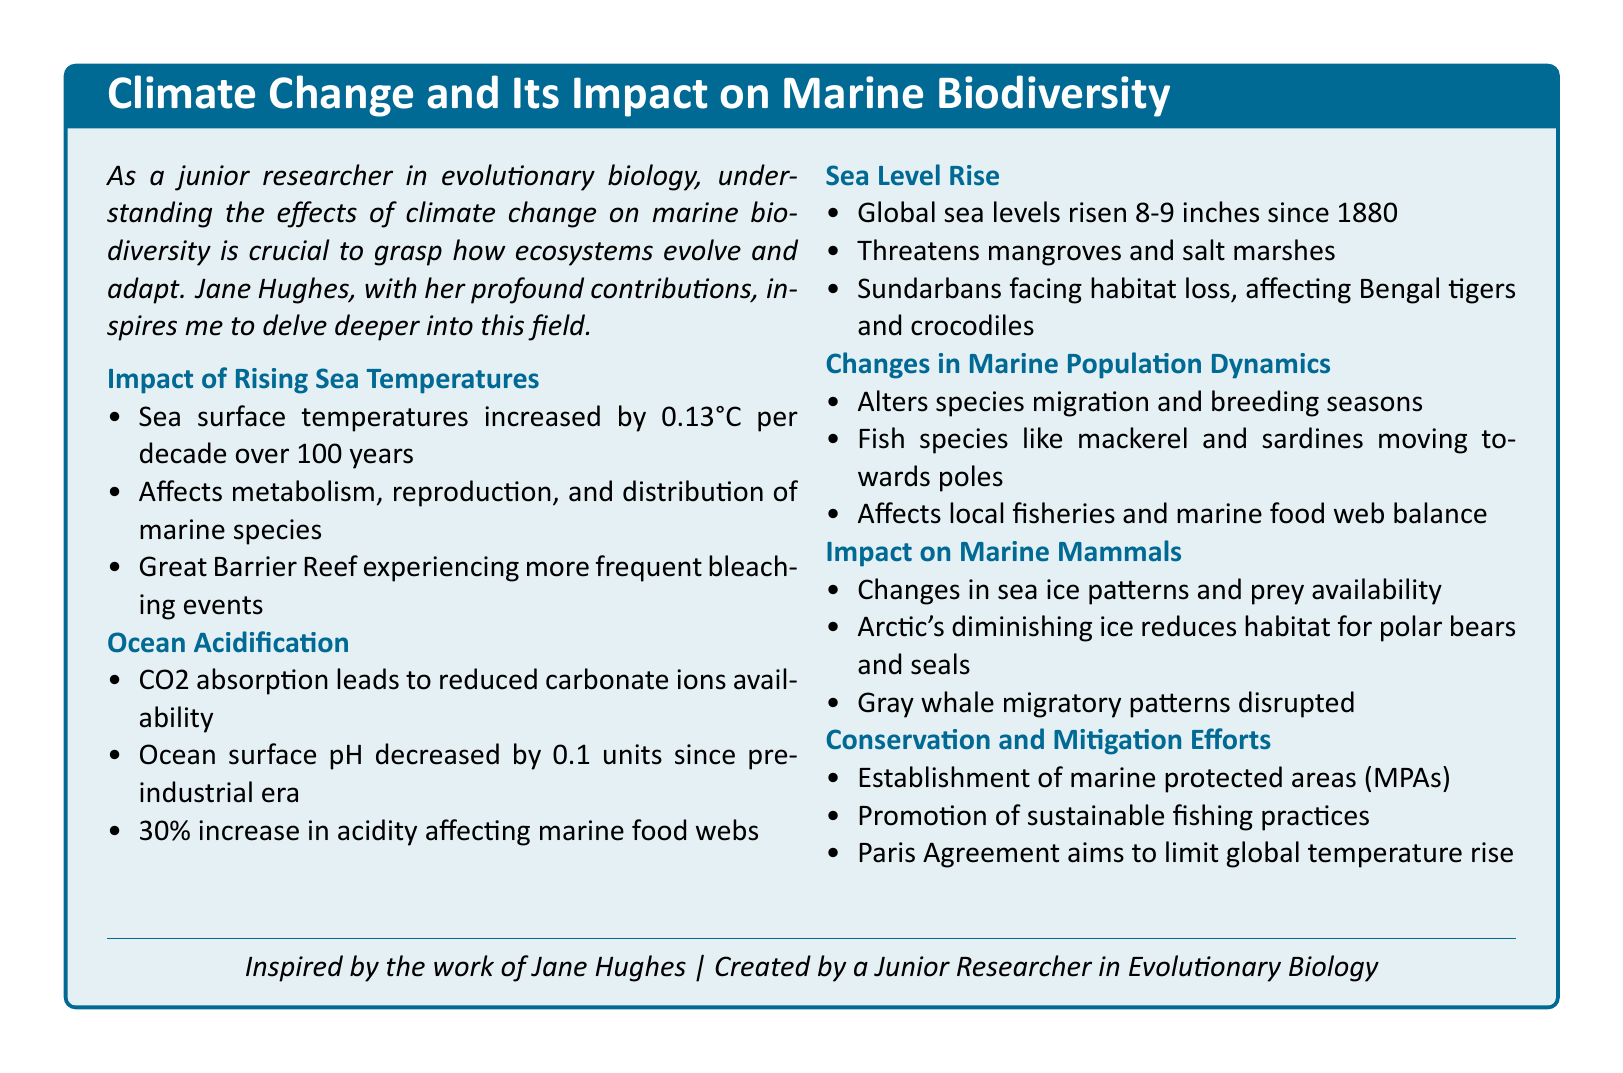What is the increase in sea surface temperatures per decade? The document states that sea surface temperatures increased by 0.13°C per decade over 100 years.
Answer: 0.13°C What is the percentage increase in ocean acidity? The document indicates a 30% increase in acidity affecting marine food webs.
Answer: 30% What habitat is threatened by rising sea levels? The document mentions that rising sea levels threaten mangroves and salt marshes.
Answer: Mangroves and salt marshes Which species are moving towards the poles? Mackerel and sardines are mentioned as fish species moving towards the poles due to changes in marine population dynamics.
Answer: Mackerel and sardines What is the impact on polar bears due to climate change? The document states that changes in sea ice patterns reduce habitat for polar bears.
Answer: Reduced habitat What does the Paris Agreement aim to limit? According to the document, the Paris Agreement aims to limit global temperature rise.
Answer: Global temperature rise What does the establishment of marine protected areas (MPAs) help with? The document suggests that the establishment of MPAs helps in conservation efforts.
Answer: Conservation efforts How much have global sea levels risen since 1880? The document notes that global sea levels have risen 8-9 inches since 1880.
Answer: 8-9 inches 